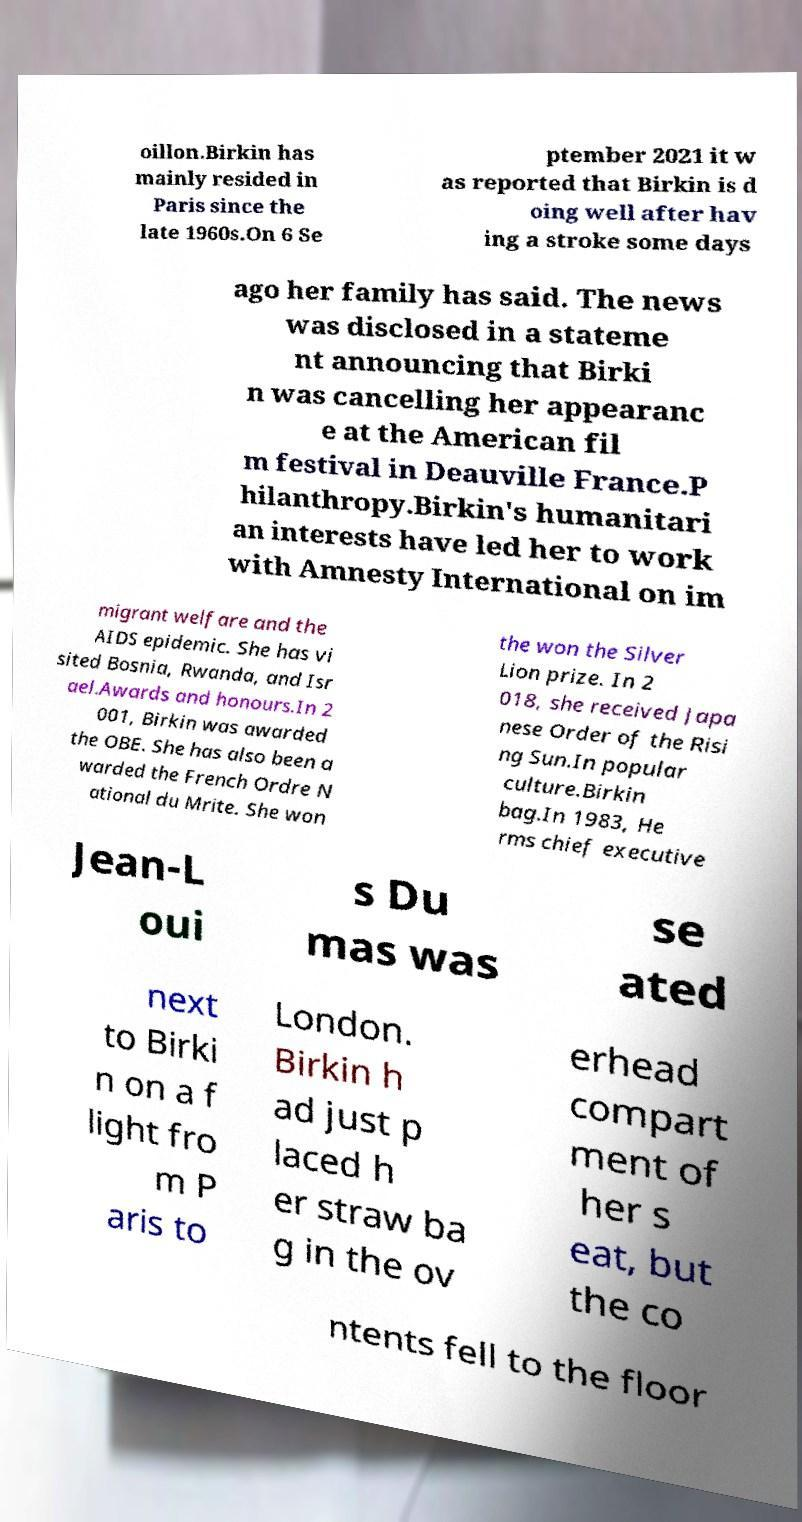What messages or text are displayed in this image? I need them in a readable, typed format. oillon.Birkin has mainly resided in Paris since the late 1960s.On 6 Se ptember 2021 it w as reported that Birkin is d oing well after hav ing a stroke some days ago her family has said. The news was disclosed in a stateme nt announcing that Birki n was cancelling her appearanc e at the American fil m festival in Deauville France.P hilanthropy.Birkin's humanitari an interests have led her to work with Amnesty International on im migrant welfare and the AIDS epidemic. She has vi sited Bosnia, Rwanda, and Isr ael.Awards and honours.In 2 001, Birkin was awarded the OBE. She has also been a warded the French Ordre N ational du Mrite. She won the won the Silver Lion prize. In 2 018, she received Japa nese Order of the Risi ng Sun.In popular culture.Birkin bag.In 1983, He rms chief executive Jean-L oui s Du mas was se ated next to Birki n on a f light fro m P aris to London. Birkin h ad just p laced h er straw ba g in the ov erhead compart ment of her s eat, but the co ntents fell to the floor 